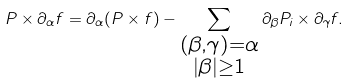<formula> <loc_0><loc_0><loc_500><loc_500>P \times \partial _ { \alpha } f = \partial _ { \alpha } ( P \times f ) - \sum _ { \substack { ( \beta , \gamma ) = \alpha \\ \left | \beta \right | \geq 1 } } \partial _ { \beta } P _ { i } \times \partial _ { \gamma } f .</formula> 